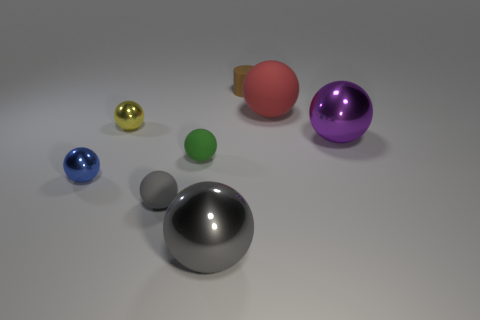Subtract 2 spheres. How many spheres are left? 5 Subtract all gray spheres. How many spheres are left? 5 Subtract all purple metallic spheres. How many spheres are left? 6 Subtract all blue balls. Subtract all purple cylinders. How many balls are left? 6 Add 2 purple shiny objects. How many objects exist? 10 Subtract all cylinders. How many objects are left? 7 Subtract all small blue metallic spheres. Subtract all small blue balls. How many objects are left? 6 Add 1 gray matte spheres. How many gray matte spheres are left? 2 Add 8 large cyan shiny balls. How many large cyan shiny balls exist? 8 Subtract 0 cyan balls. How many objects are left? 8 